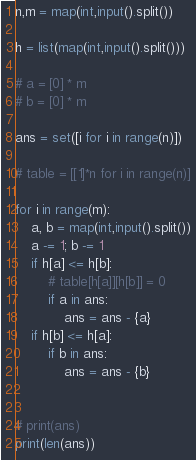<code> <loc_0><loc_0><loc_500><loc_500><_Python_>

n,m = map(int,input().split())

h = list(map(int,input().split()))

# a = [0] * m
# b = [0] * m

ans = set([i for i in range(n)])

# table = [[1]*n for i in range(n)]

for i in range(m):
    a, b = map(int,input().split())
    a -= 1; b -= 1
    if h[a] <= h[b]:
        # table[h[a]][h[b]] = 0
        if a in ans:
            ans = ans - {a}
    if h[b] <= h[a]:
        if b in ans:
            ans = ans - {b}
        

# print(ans)
print(len(ans))
</code> 